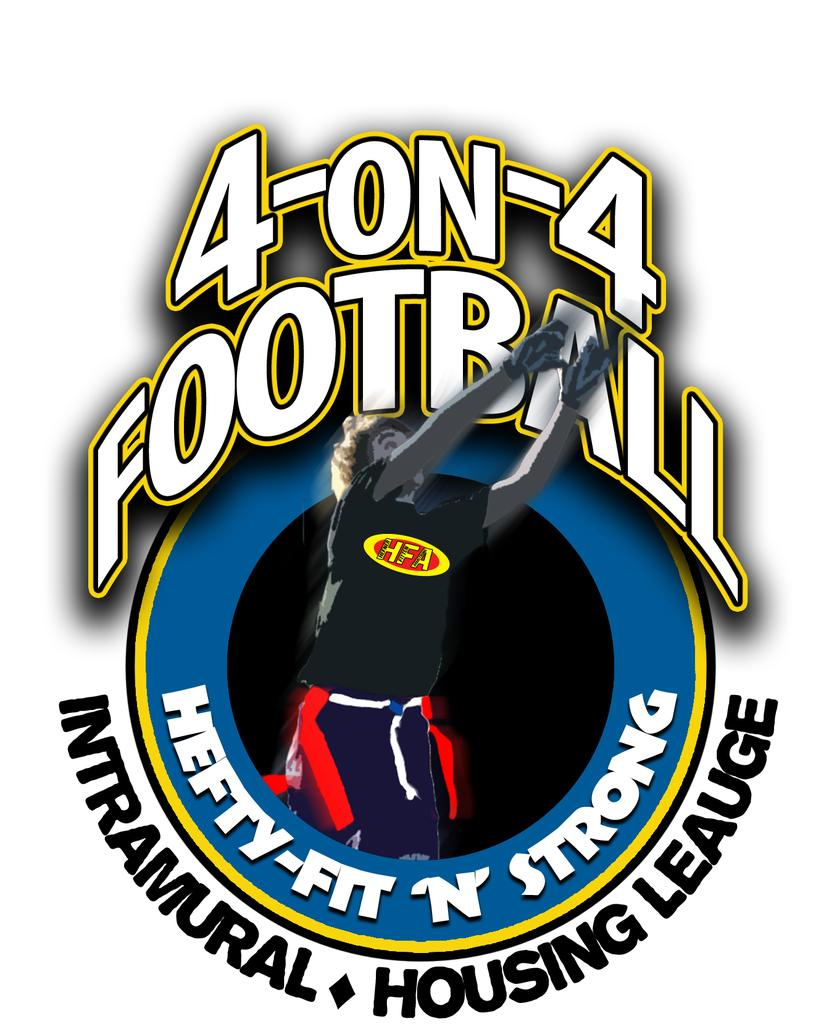<image>
Relay a brief, clear account of the picture shown. a person that is jumping under a 4 on 4 football logo 